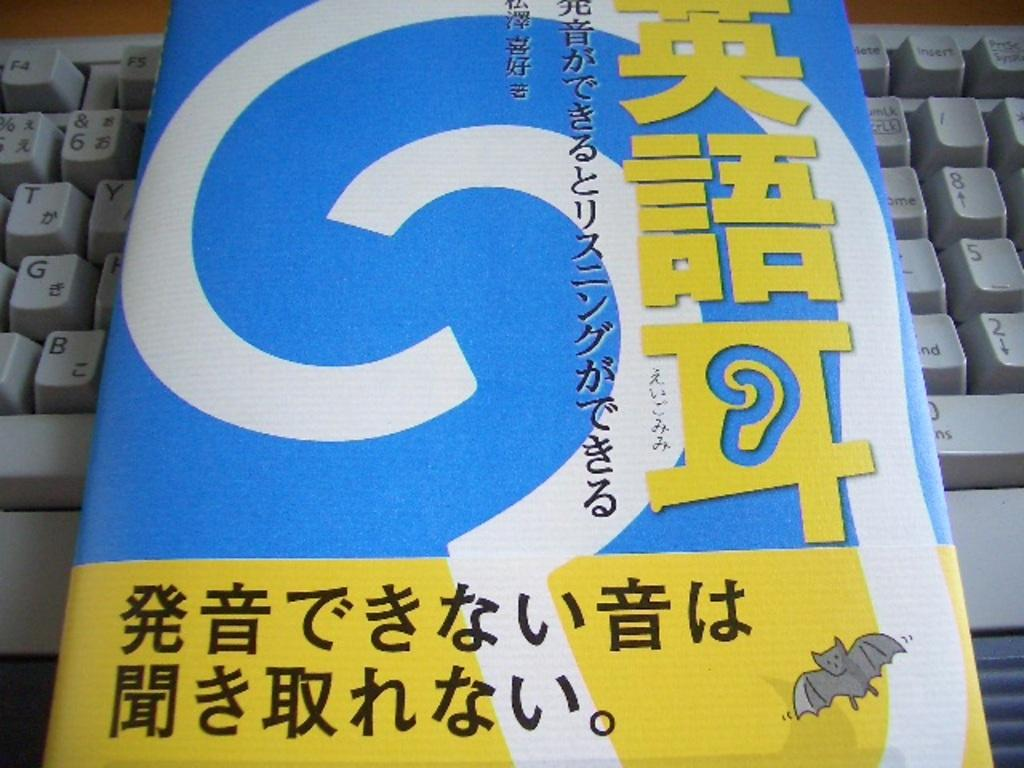<image>
Present a compact description of the photo's key features. a book with Japanese letters on a keyboard with T and G keys 